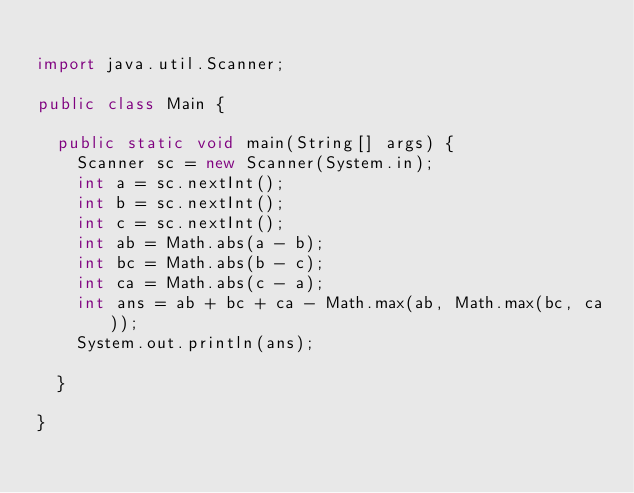Convert code to text. <code><loc_0><loc_0><loc_500><loc_500><_Java_>
import java.util.Scanner;

public class Main {

	public static void main(String[] args) {
		Scanner sc = new Scanner(System.in);
		int a = sc.nextInt();
		int b = sc.nextInt();
		int c = sc.nextInt();
		int ab = Math.abs(a - b);
		int bc = Math.abs(b - c);
		int ca = Math.abs(c - a);
		int ans = ab + bc + ca - Math.max(ab, Math.max(bc, ca));
		System.out.println(ans);

	}

}
</code> 